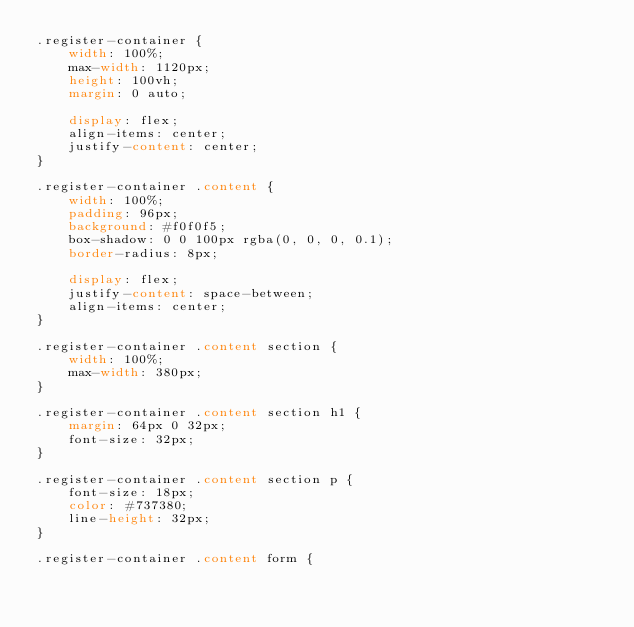Convert code to text. <code><loc_0><loc_0><loc_500><loc_500><_CSS_>.register-container {
    width: 100%;
    max-width: 1120px;
    height: 100vh;
    margin: 0 auto;

    display: flex;
    align-items: center;
    justify-content: center;
}

.register-container .content {
    width: 100%;
    padding: 96px;
    background: #f0f0f5;
    box-shadow: 0 0 100px rgba(0, 0, 0, 0.1);
    border-radius: 8px;

    display: flex;
    justify-content: space-between;
    align-items: center;
}

.register-container .content section {
    width: 100%;
    max-width: 380px;
}

.register-container .content section h1 {
    margin: 64px 0 32px;
    font-size: 32px;
}

.register-container .content section p {
    font-size: 18px;
    color: #737380;
    line-height: 32px;
}

.register-container .content form {</code> 